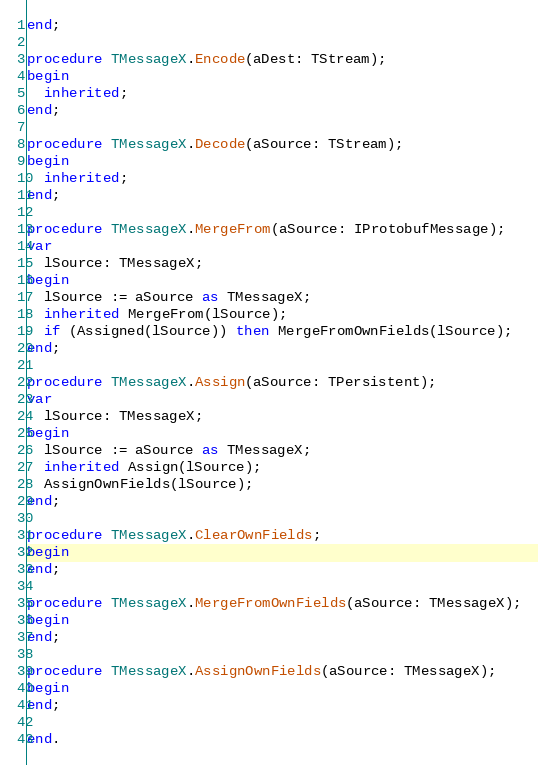Convert code to text. <code><loc_0><loc_0><loc_500><loc_500><_Pascal_>end;

procedure TMessageX.Encode(aDest: TStream);
begin
  inherited;
end;

procedure TMessageX.Decode(aSource: TStream);
begin
  inherited;
end;

procedure TMessageX.MergeFrom(aSource: IProtobufMessage);
var
  lSource: TMessageX;
begin
  lSource := aSource as TMessageX;
  inherited MergeFrom(lSource);
  if (Assigned(lSource)) then MergeFromOwnFields(lSource);
end;

procedure TMessageX.Assign(aSource: TPersistent);
var
  lSource: TMessageX;
begin
  lSource := aSource as TMessageX;
  inherited Assign(lSource);
  AssignOwnFields(lSource);
end;

procedure TMessageX.ClearOwnFields;
begin
end;

procedure TMessageX.MergeFromOwnFields(aSource: TMessageX);
begin
end;

procedure TMessageX.AssignOwnFields(aSource: TMessageX);
begin
end;

end.
</code> 